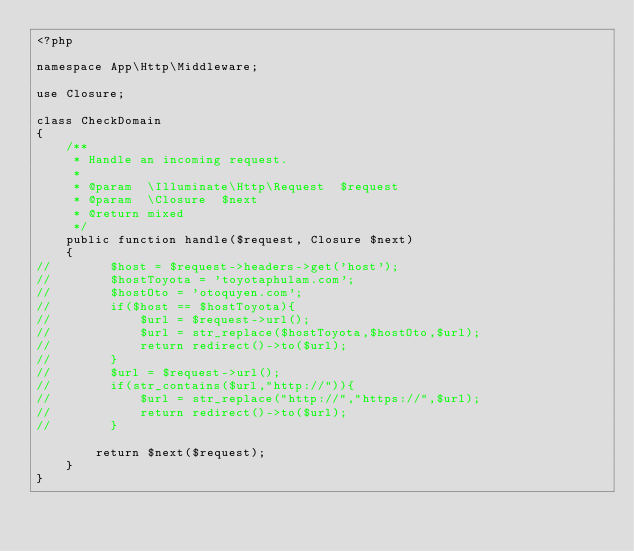<code> <loc_0><loc_0><loc_500><loc_500><_PHP_><?php

namespace App\Http\Middleware;

use Closure;

class CheckDomain
{
    /**
     * Handle an incoming request.
     *
     * @param  \Illuminate\Http\Request  $request
     * @param  \Closure  $next
     * @return mixed
     */
    public function handle($request, Closure $next)
    {
//        $host = $request->headers->get('host');
//        $hostToyota = 'toyotaphulam.com';
//        $hostOto = 'otoquyen.com';
//        if($host == $hostToyota){
//            $url = $request->url();
//            $url = str_replace($hostToyota,$hostOto,$url);
//            return redirect()->to($url);
//        }
//        $url = $request->url();
//        if(str_contains($url,"http://")){
//            $url = str_replace("http://","https://",$url);
//            return redirect()->to($url);
//        }

        return $next($request);
    }
}
</code> 